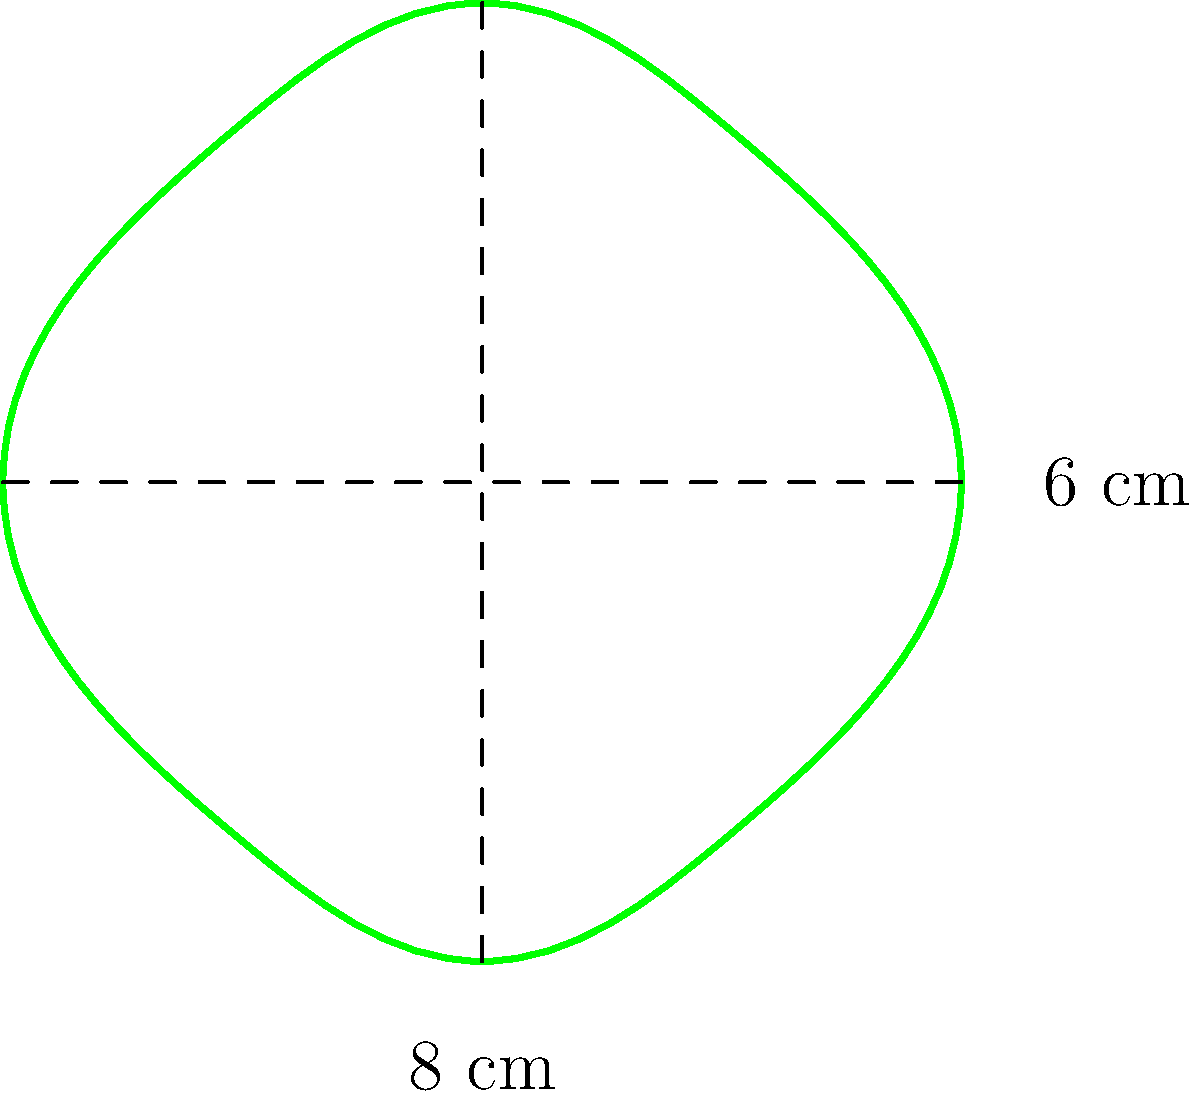An eco-friendly film festival uses a leaf-shaped logo for its promotional materials. The logo's dimensions are 8 cm in width and 6 cm in height, as shown in the figure. To estimate the amount of eco-friendly ink needed for printing, you need to calculate the approximate area of the logo. Assuming the leaf shape can be approximated by an ellipse, what is the area of the logo in square centimeters? To solve this problem, we'll follow these steps:

1) The formula for the area of an ellipse is:
   $$A = \pi \cdot a \cdot b$$
   where $a$ and $b$ are the semi-major and semi-minor axes respectively.

2) In this case:
   - The width of the logo is 8 cm, so the semi-major axis $a = 4$ cm
   - The height of the logo is 6 cm, so the semi-minor axis $b = 3$ cm

3) Substituting these values into the formula:
   $$A = \pi \cdot 4 \cdot 3$$

4) Simplify:
   $$A = 12\pi$$

5) Calculate the final value (rounded to two decimal places):
   $$A \approx 37.70 \text{ cm}^2$$

Therefore, the approximate area of the leaf-shaped logo is 37.70 square centimeters.
Answer: $37.70 \text{ cm}^2$ 